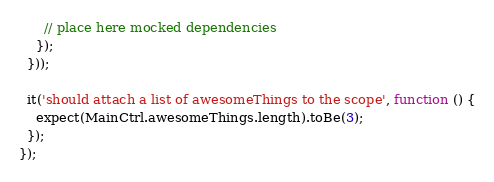<code> <loc_0><loc_0><loc_500><loc_500><_JavaScript_>      // place here mocked dependencies
    });
  }));

  it('should attach a list of awesomeThings to the scope', function () {
    expect(MainCtrl.awesomeThings.length).toBe(3);
  });
});
</code> 